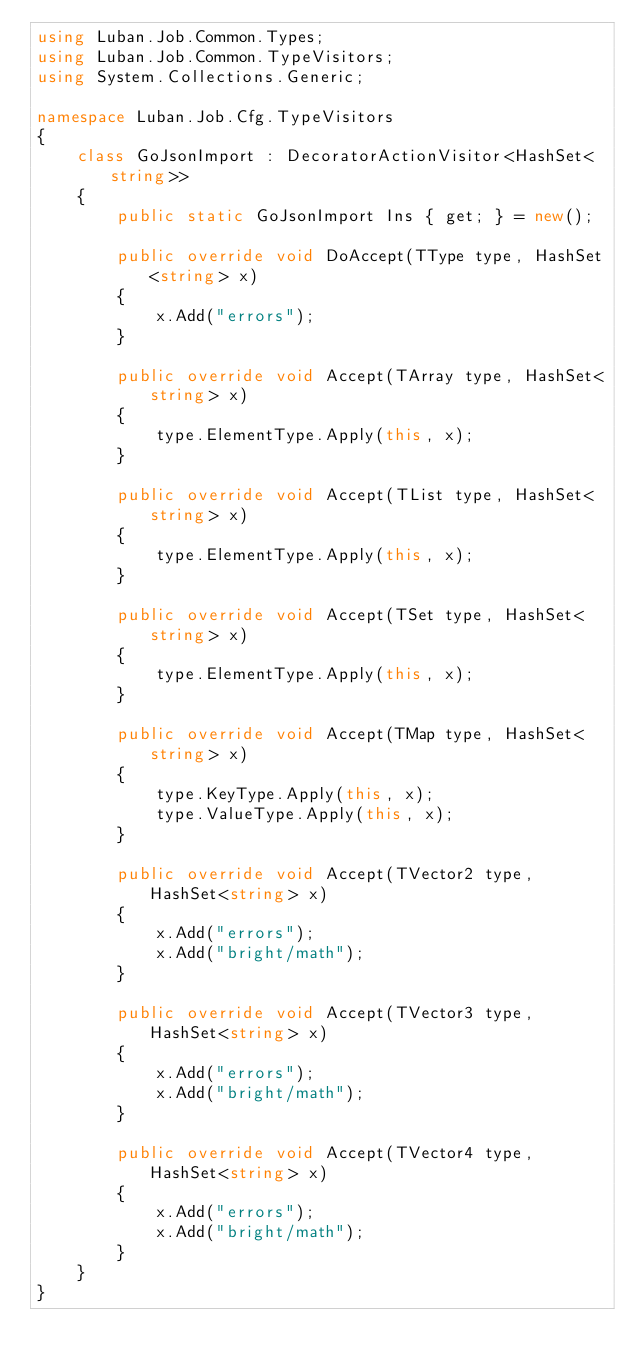<code> <loc_0><loc_0><loc_500><loc_500><_C#_>using Luban.Job.Common.Types;
using Luban.Job.Common.TypeVisitors;
using System.Collections.Generic;

namespace Luban.Job.Cfg.TypeVisitors
{
    class GoJsonImport : DecoratorActionVisitor<HashSet<string>>
    {
        public static GoJsonImport Ins { get; } = new();

        public override void DoAccept(TType type, HashSet<string> x)
        {
            x.Add("errors");
        }

        public override void Accept(TArray type, HashSet<string> x)
        {
            type.ElementType.Apply(this, x);
        }

        public override void Accept(TList type, HashSet<string> x)
        {
            type.ElementType.Apply(this, x);
        }

        public override void Accept(TSet type, HashSet<string> x)
        {
            type.ElementType.Apply(this, x);
        }

        public override void Accept(TMap type, HashSet<string> x)
        {
            type.KeyType.Apply(this, x);
            type.ValueType.Apply(this, x);
        }

        public override void Accept(TVector2 type, HashSet<string> x)
        {
            x.Add("errors");
            x.Add("bright/math");
        }

        public override void Accept(TVector3 type, HashSet<string> x)
        {
            x.Add("errors");
            x.Add("bright/math");
        }

        public override void Accept(TVector4 type, HashSet<string> x)
        {
            x.Add("errors");
            x.Add("bright/math");
        }
    }
}
</code> 